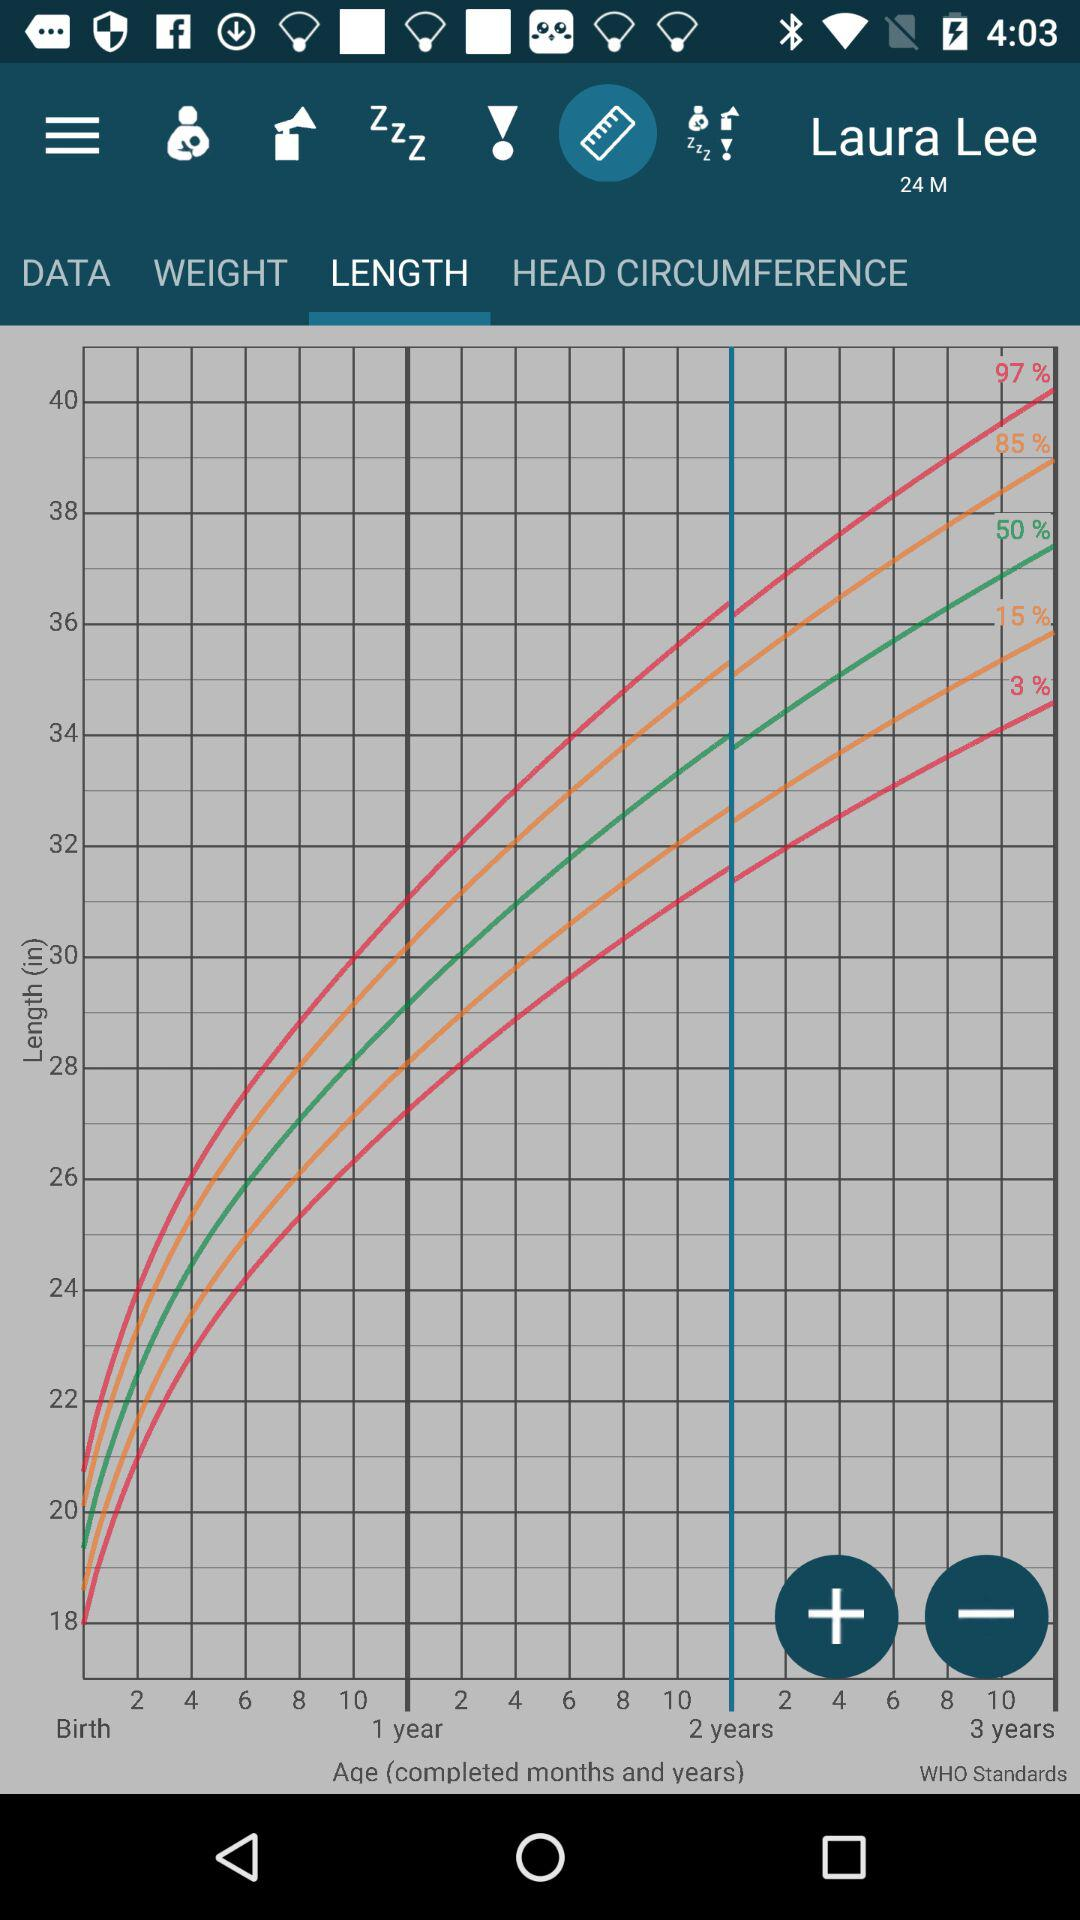What is the baby name? The baby name is Laura Lee. 